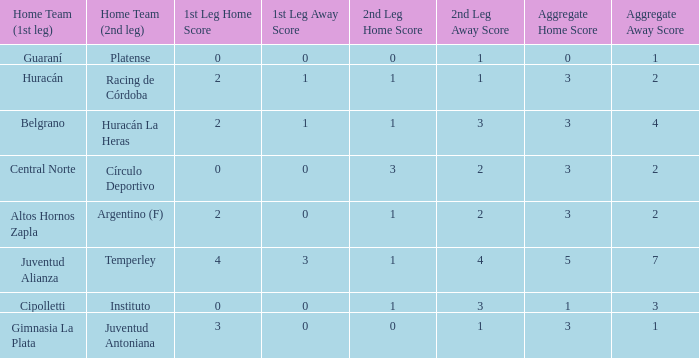What was the score of the 2nd leg when the Belgrano played the first leg at home with a score of 2-1? 1-3. 